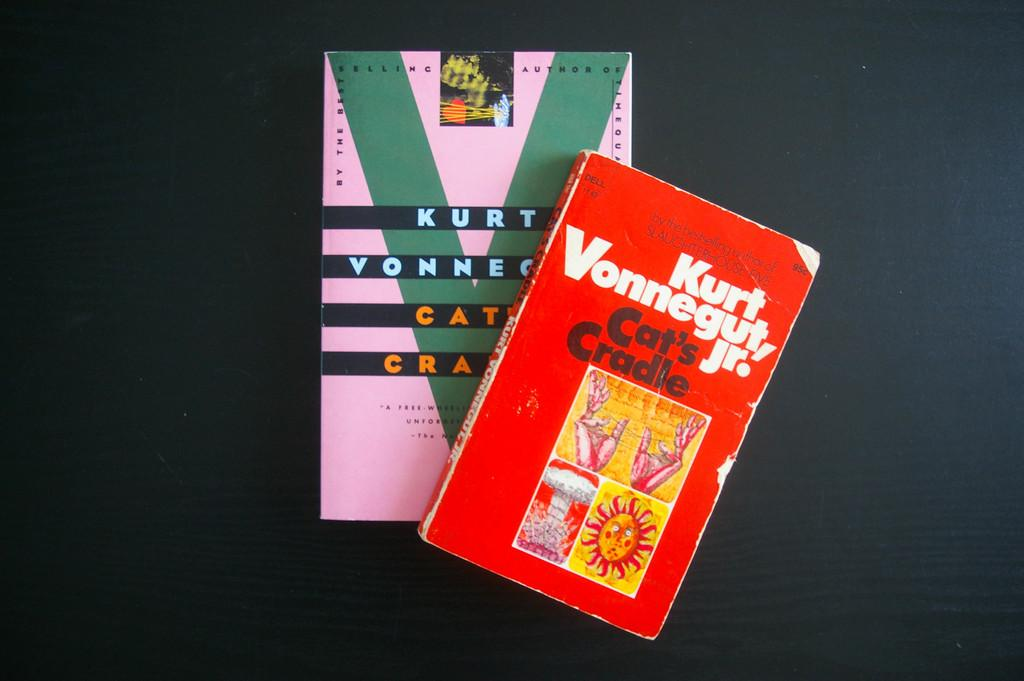Provide a one-sentence caption for the provided image. Two books written by Kurt Vonnegut Jr. sitting on a black table. 